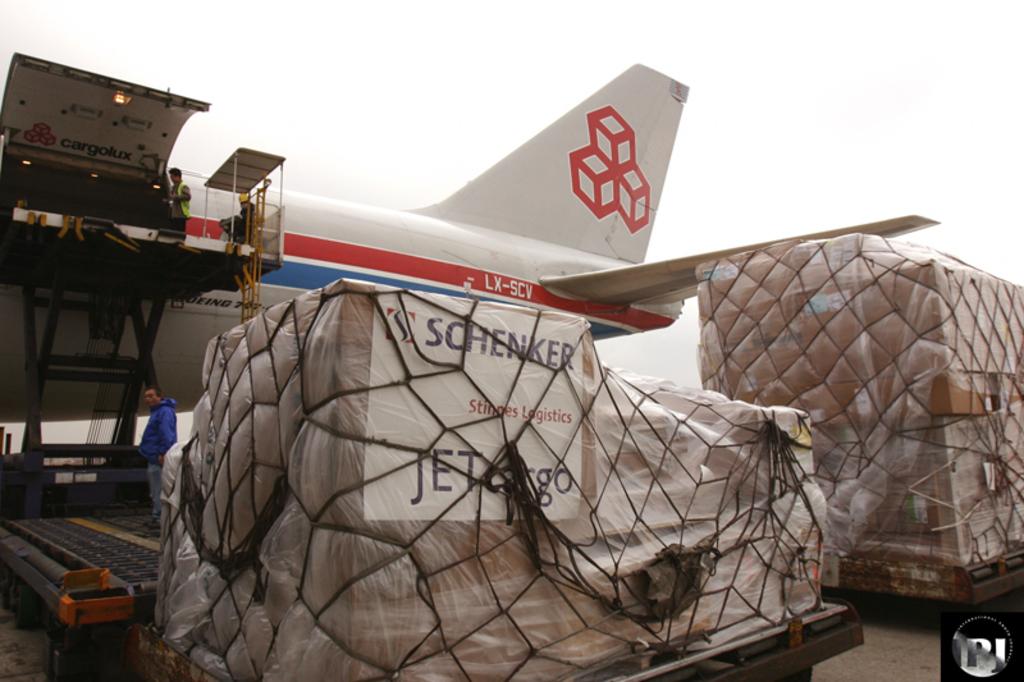What company is mentioned on the cargo label?
Your response must be concise. Schenker. What are the letters on the tail of the plane?
Ensure brevity in your answer.  Lx-scv. 